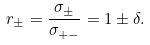<formula> <loc_0><loc_0><loc_500><loc_500>r _ { \pm } = \frac { \sigma _ { \pm } } { \sigma _ { + - } } = 1 \pm \delta .</formula> 